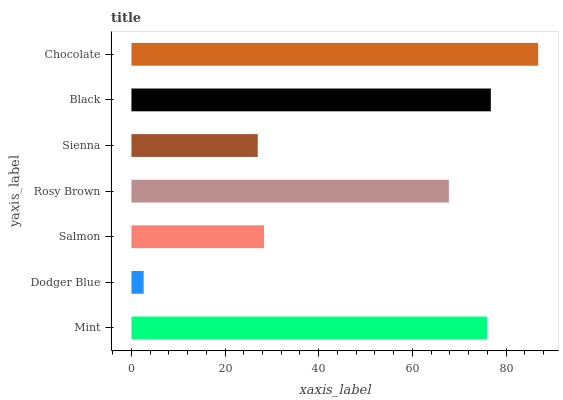Is Dodger Blue the minimum?
Answer yes or no. Yes. Is Chocolate the maximum?
Answer yes or no. Yes. Is Salmon the minimum?
Answer yes or no. No. Is Salmon the maximum?
Answer yes or no. No. Is Salmon greater than Dodger Blue?
Answer yes or no. Yes. Is Dodger Blue less than Salmon?
Answer yes or no. Yes. Is Dodger Blue greater than Salmon?
Answer yes or no. No. Is Salmon less than Dodger Blue?
Answer yes or no. No. Is Rosy Brown the high median?
Answer yes or no. Yes. Is Rosy Brown the low median?
Answer yes or no. Yes. Is Mint the high median?
Answer yes or no. No. Is Chocolate the low median?
Answer yes or no. No. 